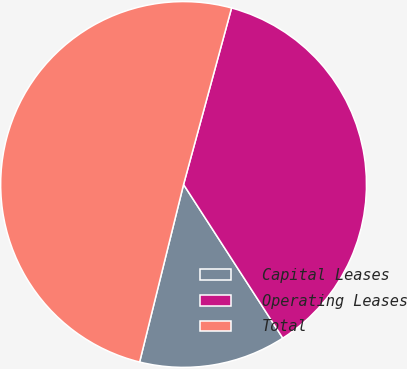<chart> <loc_0><loc_0><loc_500><loc_500><pie_chart><fcel>Capital Leases<fcel>Operating Leases<fcel>Total<nl><fcel>12.99%<fcel>36.65%<fcel>50.37%<nl></chart> 